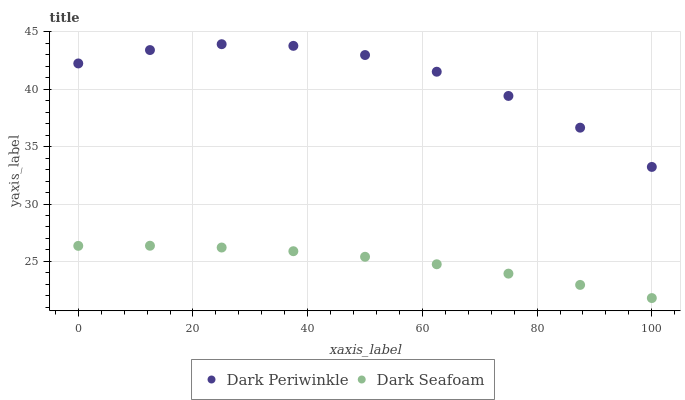Does Dark Seafoam have the minimum area under the curve?
Answer yes or no. Yes. Does Dark Periwinkle have the maximum area under the curve?
Answer yes or no. Yes. Does Dark Periwinkle have the minimum area under the curve?
Answer yes or no. No. Is Dark Seafoam the smoothest?
Answer yes or no. Yes. Is Dark Periwinkle the roughest?
Answer yes or no. Yes. Is Dark Periwinkle the smoothest?
Answer yes or no. No. Does Dark Seafoam have the lowest value?
Answer yes or no. Yes. Does Dark Periwinkle have the lowest value?
Answer yes or no. No. Does Dark Periwinkle have the highest value?
Answer yes or no. Yes. Is Dark Seafoam less than Dark Periwinkle?
Answer yes or no. Yes. Is Dark Periwinkle greater than Dark Seafoam?
Answer yes or no. Yes. Does Dark Seafoam intersect Dark Periwinkle?
Answer yes or no. No. 